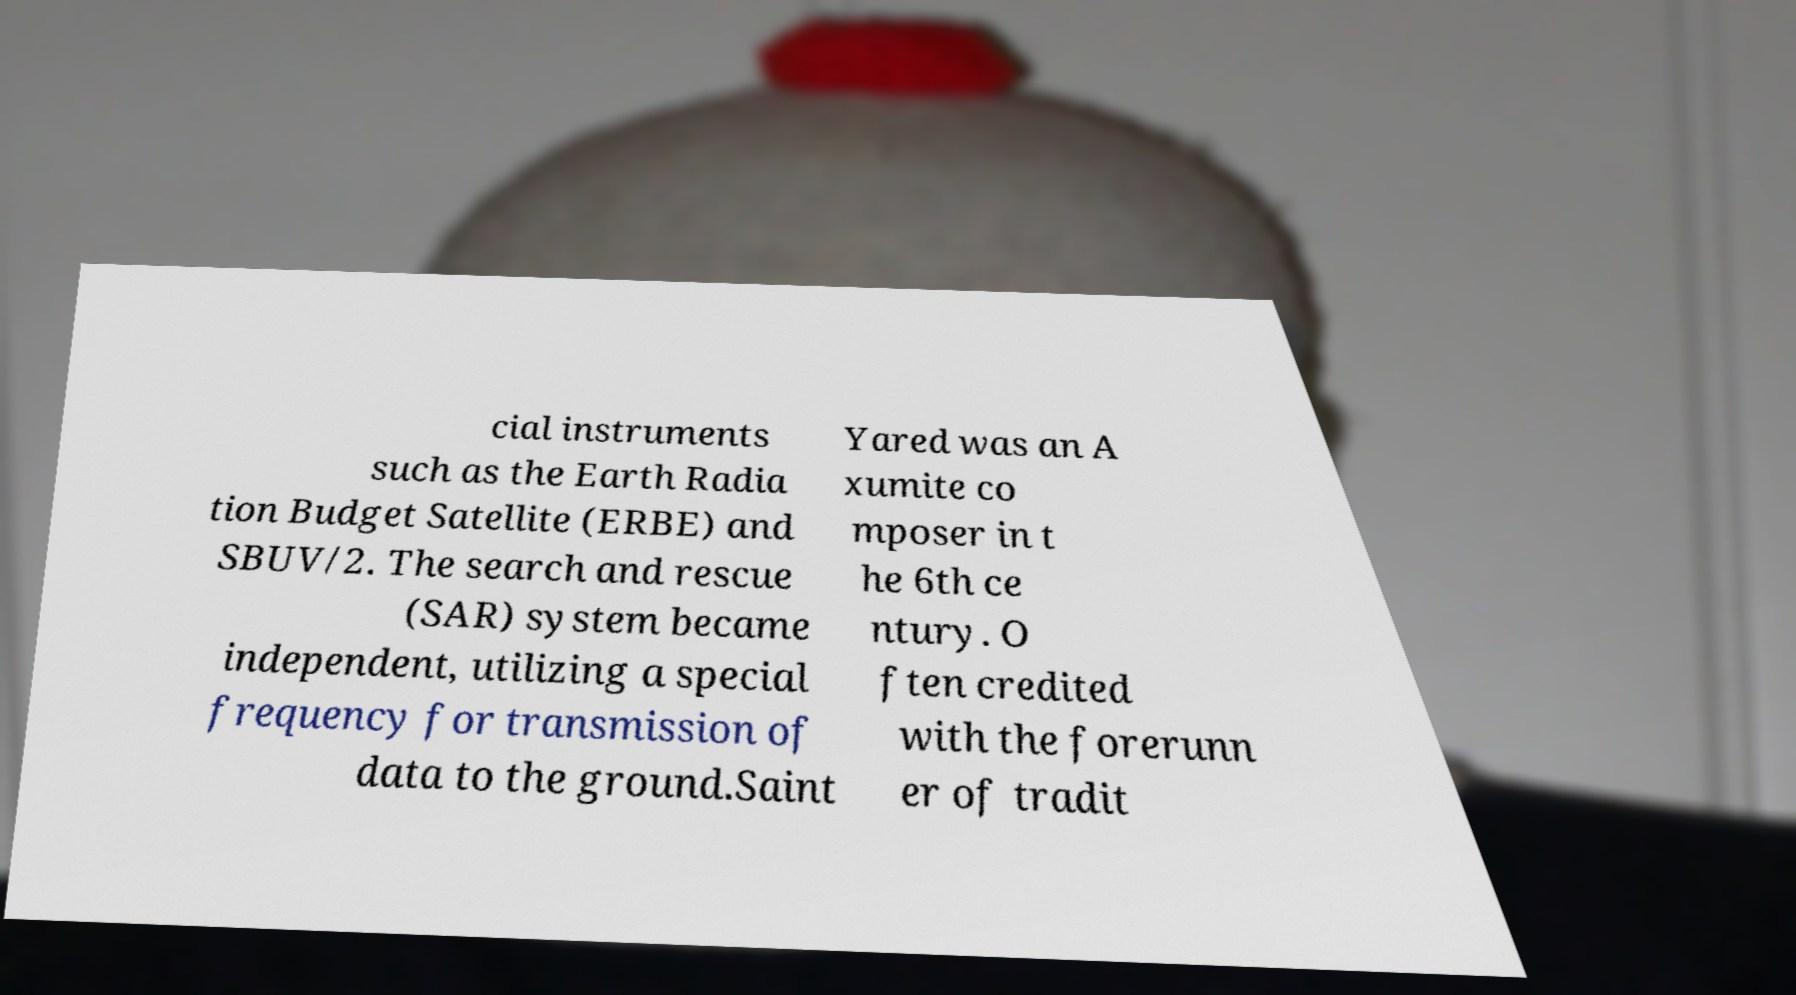Please identify and transcribe the text found in this image. cial instruments such as the Earth Radia tion Budget Satellite (ERBE) and SBUV/2. The search and rescue (SAR) system became independent, utilizing a special frequency for transmission of data to the ground.Saint Yared was an A xumite co mposer in t he 6th ce ntury. O ften credited with the forerunn er of tradit 